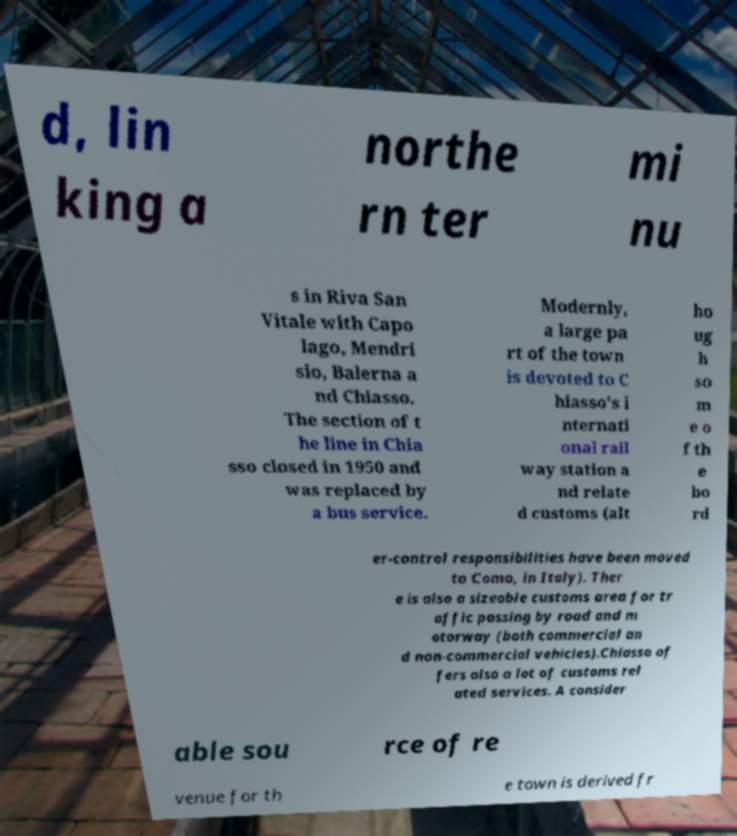For documentation purposes, I need the text within this image transcribed. Could you provide that? d, lin king a northe rn ter mi nu s in Riva San Vitale with Capo lago, Mendri sio, Balerna a nd Chiasso. The section of t he line in Chia sso closed in 1950 and was replaced by a bus service. Modernly, a large pa rt of the town is devoted to C hiasso's i nternati onal rail way station a nd relate d customs (alt ho ug h so m e o f th e bo rd er-control responsibilities have been moved to Como, in Italy). Ther e is also a sizeable customs area for tr affic passing by road and m otorway (both commercial an d non-commercial vehicles).Chiasso of fers also a lot of customs rel ated services. A consider able sou rce of re venue for th e town is derived fr 